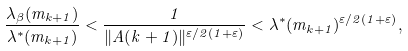Convert formula to latex. <formula><loc_0><loc_0><loc_500><loc_500>\frac { \lambda _ { \beta } ( m _ { k + 1 } ) } { \lambda ^ { * } ( m _ { k + 1 } ) } < \frac { 1 } { \| A ( k + 1 ) \| ^ { \varepsilon / 2 ( 1 + \varepsilon ) } } < \lambda ^ { * } ( m _ { k + 1 } ) ^ { \varepsilon / 2 ( 1 + \varepsilon ) } ,</formula> 